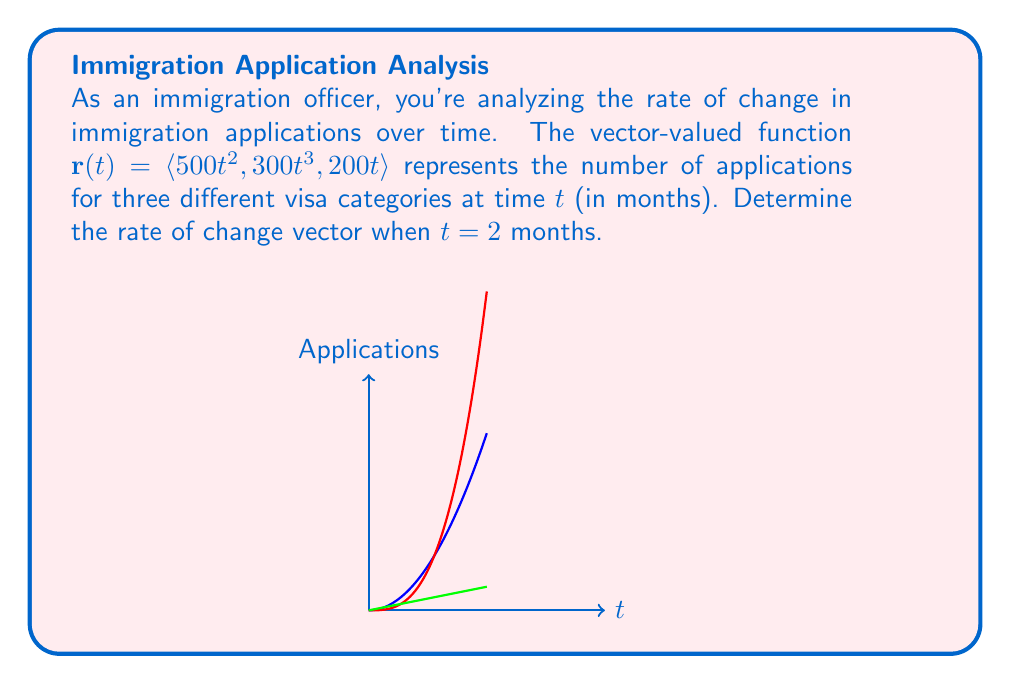Can you answer this question? To find the rate of change vector, we need to calculate the derivative of the vector-valued function $\mathbf{r}(t)$ with respect to $t$ and then evaluate it at $t = 2$.

Step 1: Calculate the derivative of $\mathbf{r}(t)$.
$$\mathbf{r}'(t) = \langle \frac{d}{dt}(500t^2), \frac{d}{dt}(300t^3), \frac{d}{dt}(200t) \rangle$$

Step 2: Apply the power rule for each component.
$$\mathbf{r}'(t) = \langle 1000t, 900t^2, 200 \rangle$$

Step 3: Evaluate $\mathbf{r}'(t)$ at $t = 2$.
$$\mathbf{r}'(2) = \langle 1000(2), 900(2^2), 200 \rangle$$
$$\mathbf{r}'(2) = \langle 2000, 3600, 200 \rangle$$

This vector represents the instantaneous rate of change for each visa category at $t = 2$ months.
Answer: $\langle 2000, 3600, 200 \rangle$ applications per month 